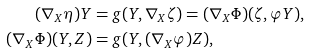Convert formula to latex. <formula><loc_0><loc_0><loc_500><loc_500>( \nabla _ { X } \eta ) Y & = g ( Y , \nabla _ { X } \zeta ) = ( \nabla _ { X } \Phi ) ( \zeta , \varphi Y ) , \\ ( \nabla _ { X } \Phi ) ( Y , Z ) & = g ( Y , ( \nabla _ { X } \varphi ) Z ) ,</formula> 